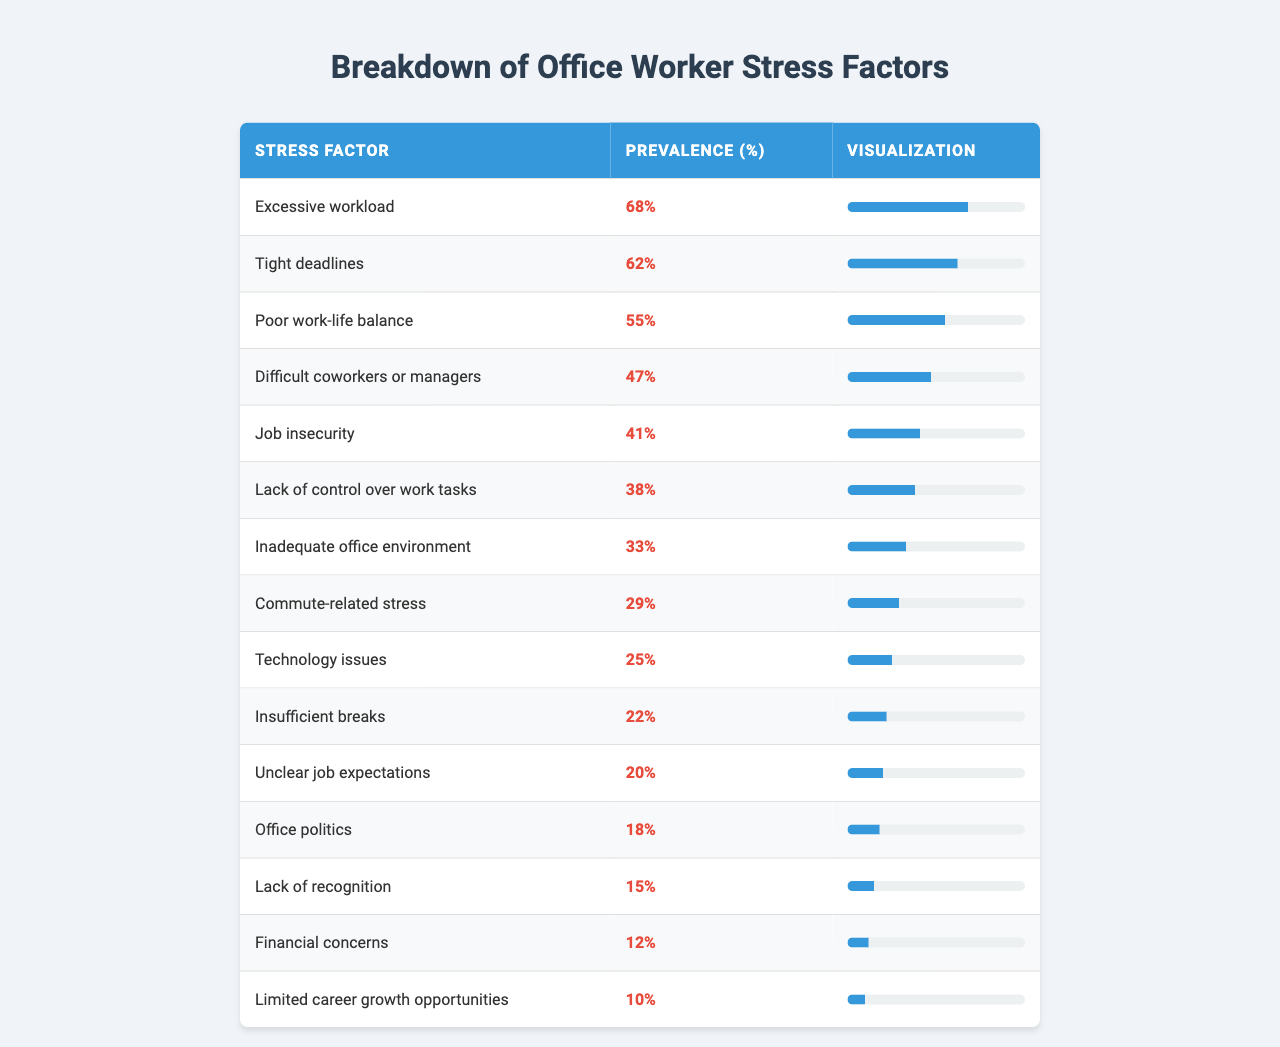What is the most prevalent stress factor among office workers? According to the table, "Excessive workload" has the highest prevalence at 68%.
Answer: 68% What is the prevalence percentage of job insecurity? The table indicates that "Job insecurity" has a prevalence percentage of 41%.
Answer: 41% How many stress factors have a prevalence of 50% or higher? The factors with 50% or higher prevalence are "Excessive workload" (68%), "Tight deadlines" (62%), and "Poor work-life balance" (55%), totaling 3 factors.
Answer: 3 What is the difference in prevalence percentages between "Technology issues" and "Insufficient breaks"? "Technology issues" has a prevalence of 25%, and "Insufficient breaks" has a prevalence of 22%. The difference is 25% - 22% = 3%.
Answer: 3% Is "Lack of recognition" a more significant stress factor than "Financial concerns"? "Lack of recognition" has a prevalence of 15%, while "Financial concerns" has a prevalence of 12%. Since 15% > 12%, the statement is true.
Answer: Yes What is the average prevalence of the top three stress factors? The top three stress factors are "Excessive workload" (68%), "Tight deadlines" (62%), and "Poor work-life balance" (55%). Their average is (68 + 62 + 55) / 3 = 61.67%.
Answer: 61.67% If we include "Limited career growth opportunities" at 10%, what would the new average of the top four factors be? Including "Limited career growth opportunities," the top four factors now are 68%, 62%, 55%, and 10%. The new average is (68 + 62 + 55 + 10) / 4 = 48.75%.
Answer: 48.75% Which stress factor is least prevalent? "Limited career growth opportunities" is the least prevalent factor, with a prevalence of 10%.
Answer: 10% How many stress factors have a prevalence of less than 30%? The factors below 30% are "Commute-related stress" (29%), "Technology issues" (25%), "Insufficient breaks" (22%), and "Financial concerns" (12%), totaling 4 factors.
Answer: 4 What is the combined prevalence percentage of "Office politics" and "Lack of recognition"? "Office politics" has a prevalence of 18%, and "Lack of recognition" has a prevalence of 15%. Therefore, the combined percentage is 18% + 15% = 33%.
Answer: 33% What percentage of office workers feel stress due to a poor work-life balance or difficult coworkers/managers? "Poor work-life balance" has a prevalence of 55%, and "Difficult coworkers or managers" has a prevalence of 47%. The combined percentage is 55% + 47% = 102%.
Answer: 102% 